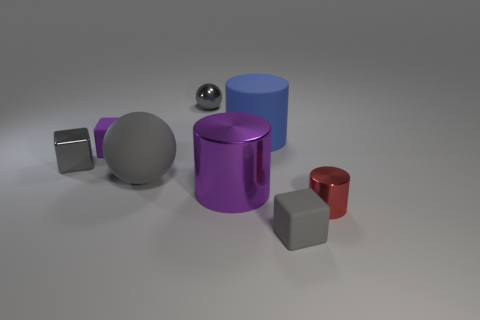Is the shape of the purple matte object the same as the big gray matte object?
Ensure brevity in your answer.  No. What is the size of the metallic block left of the large rubber thing that is to the right of the gray metal thing that is on the right side of the small purple matte object?
Provide a short and direct response. Small. There is a large blue object that is the same shape as the purple metal thing; what is its material?
Make the answer very short. Rubber. Is there any other thing that is the same size as the purple cube?
Your response must be concise. Yes. There is a block that is on the right side of the large cylinder to the left of the blue cylinder; how big is it?
Give a very brief answer. Small. The metallic sphere is what color?
Offer a very short reply. Gray. What number of big balls are behind the tiny gray thing that is on the left side of the shiny sphere?
Your response must be concise. 0. Are there any gray cubes left of the big blue matte thing to the right of the big rubber ball?
Keep it short and to the point. Yes. There is a small purple rubber cube; are there any large gray rubber balls in front of it?
Your answer should be very brief. Yes. There is a gray thing behind the blue cylinder; is it the same shape as the large purple shiny thing?
Offer a very short reply. No. 